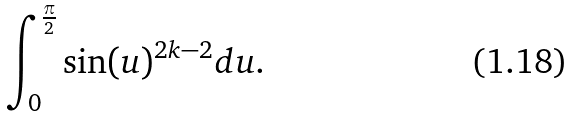<formula> <loc_0><loc_0><loc_500><loc_500>\int _ { 0 } ^ { \frac { \pi } { 2 } } \sin ( u ) ^ { 2 k - 2 } d u .</formula> 